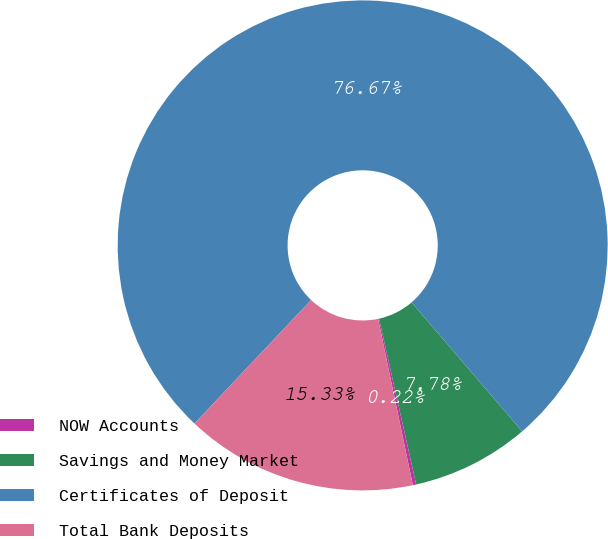Convert chart. <chart><loc_0><loc_0><loc_500><loc_500><pie_chart><fcel>NOW Accounts<fcel>Savings and Money Market<fcel>Certificates of Deposit<fcel>Total Bank Deposits<nl><fcel>0.22%<fcel>7.78%<fcel>76.67%<fcel>15.33%<nl></chart> 